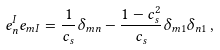Convert formula to latex. <formula><loc_0><loc_0><loc_500><loc_500>e _ { n } ^ { I } e _ { m I } = \frac { 1 } { c _ { s } } \delta _ { m n } - \frac { 1 - c _ { s } ^ { 2 } } { c _ { s } } \delta _ { m 1 } \delta _ { n 1 } \, ,</formula> 